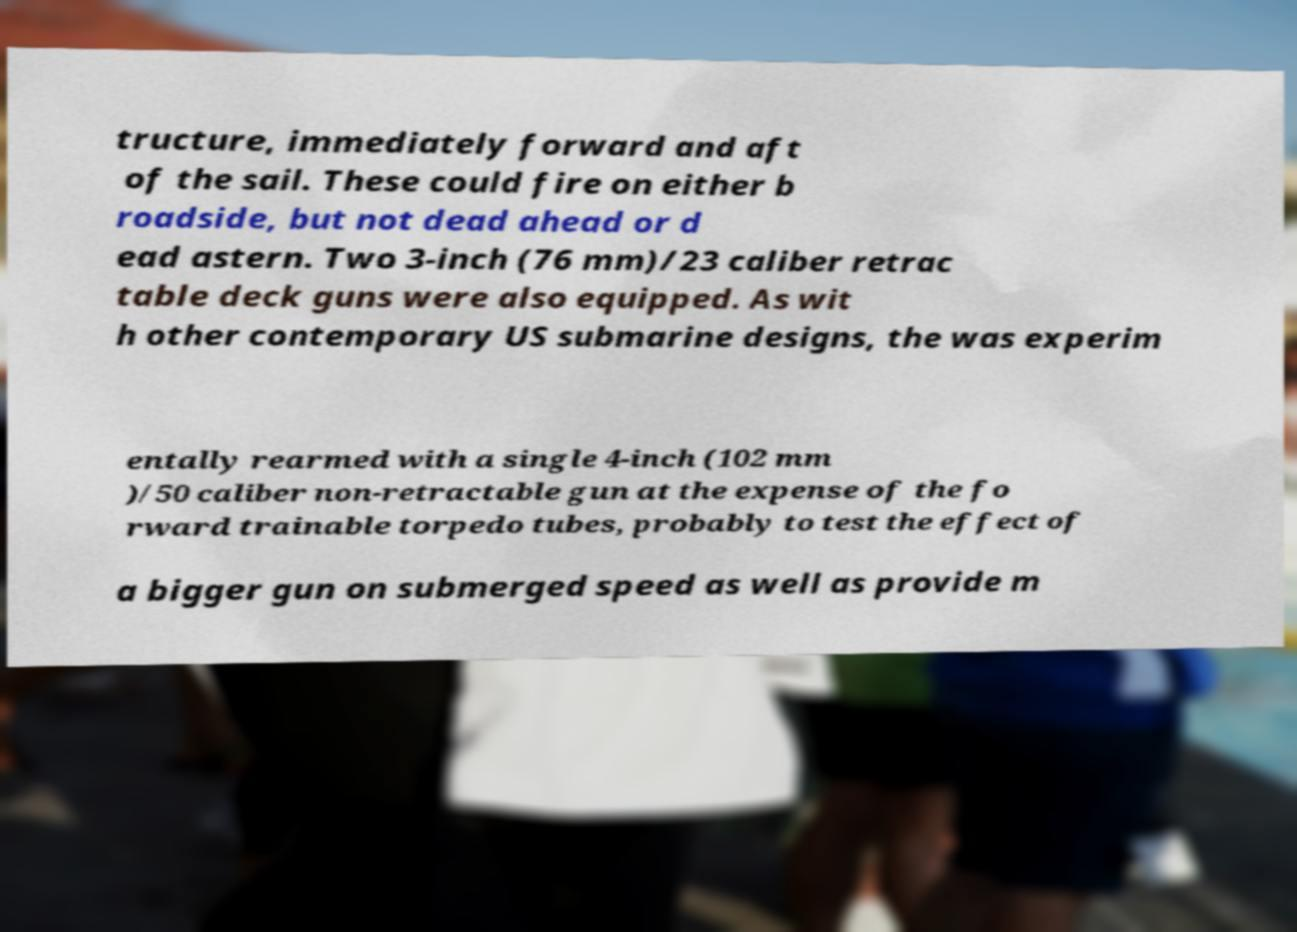Please read and relay the text visible in this image. What does it say? tructure, immediately forward and aft of the sail. These could fire on either b roadside, but not dead ahead or d ead astern. Two 3-inch (76 mm)/23 caliber retrac table deck guns were also equipped. As wit h other contemporary US submarine designs, the was experim entally rearmed with a single 4-inch (102 mm )/50 caliber non-retractable gun at the expense of the fo rward trainable torpedo tubes, probably to test the effect of a bigger gun on submerged speed as well as provide m 